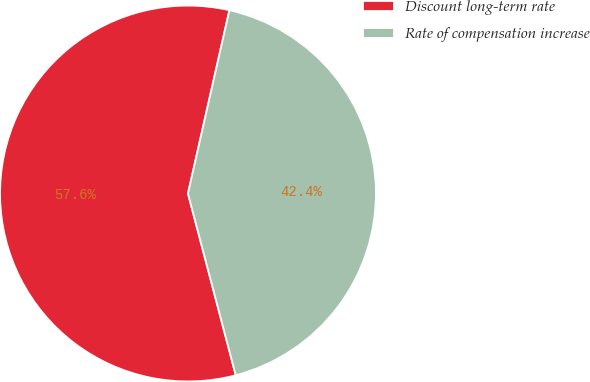Convert chart to OTSL. <chart><loc_0><loc_0><loc_500><loc_500><pie_chart><fcel>Discount long-term rate<fcel>Rate of compensation increase<nl><fcel>57.63%<fcel>42.37%<nl></chart> 